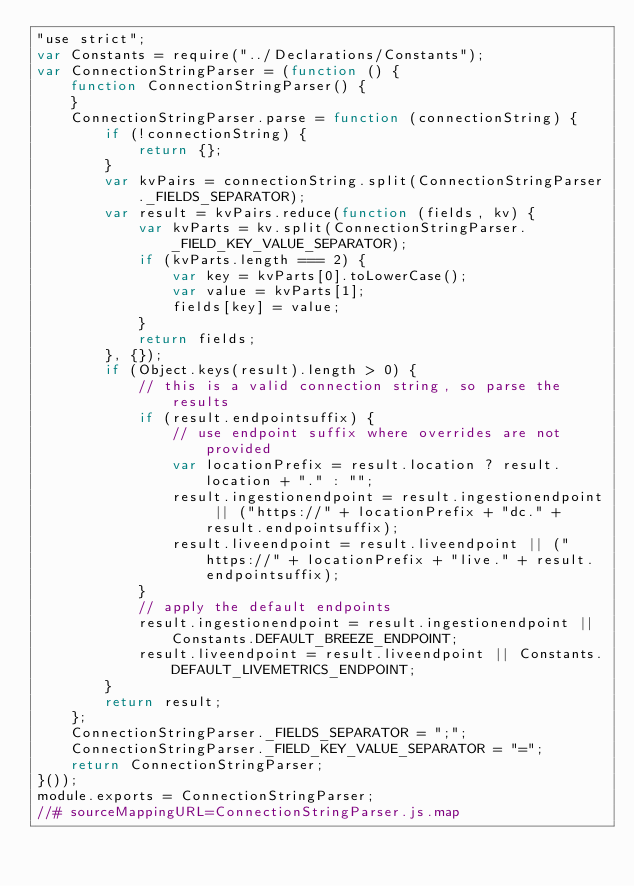<code> <loc_0><loc_0><loc_500><loc_500><_JavaScript_>"use strict";
var Constants = require("../Declarations/Constants");
var ConnectionStringParser = (function () {
    function ConnectionStringParser() {
    }
    ConnectionStringParser.parse = function (connectionString) {
        if (!connectionString) {
            return {};
        }
        var kvPairs = connectionString.split(ConnectionStringParser._FIELDS_SEPARATOR);
        var result = kvPairs.reduce(function (fields, kv) {
            var kvParts = kv.split(ConnectionStringParser._FIELD_KEY_VALUE_SEPARATOR);
            if (kvParts.length === 2) {
                var key = kvParts[0].toLowerCase();
                var value = kvParts[1];
                fields[key] = value;
            }
            return fields;
        }, {});
        if (Object.keys(result).length > 0) {
            // this is a valid connection string, so parse the results
            if (result.endpointsuffix) {
                // use endpoint suffix where overrides are not provided
                var locationPrefix = result.location ? result.location + "." : "";
                result.ingestionendpoint = result.ingestionendpoint || ("https://" + locationPrefix + "dc." + result.endpointsuffix);
                result.liveendpoint = result.liveendpoint || ("https://" + locationPrefix + "live." + result.endpointsuffix);
            }
            // apply the default endpoints
            result.ingestionendpoint = result.ingestionendpoint || Constants.DEFAULT_BREEZE_ENDPOINT;
            result.liveendpoint = result.liveendpoint || Constants.DEFAULT_LIVEMETRICS_ENDPOINT;
        }
        return result;
    };
    ConnectionStringParser._FIELDS_SEPARATOR = ";";
    ConnectionStringParser._FIELD_KEY_VALUE_SEPARATOR = "=";
    return ConnectionStringParser;
}());
module.exports = ConnectionStringParser;
//# sourceMappingURL=ConnectionStringParser.js.map</code> 